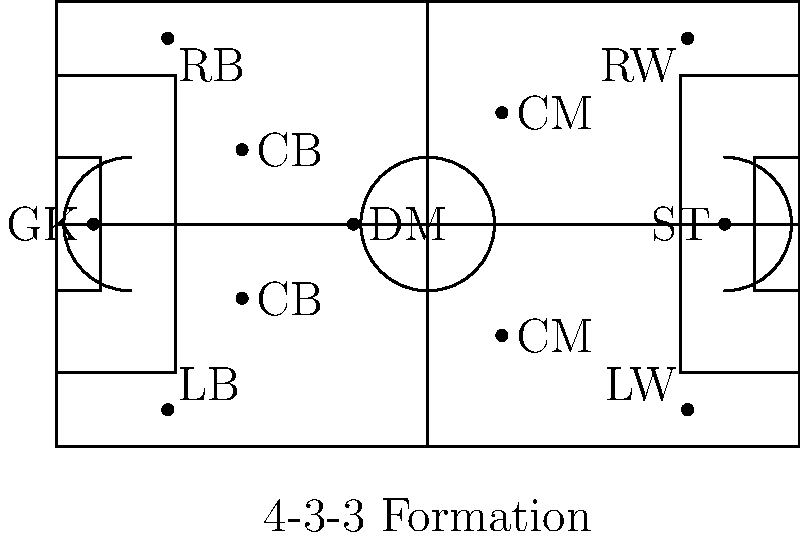Based on the diagram, which tactical formation is depicted, and how does it differ from the traditional 4-4-2 formation that was popular in Chilean football during the 1990s and early 2000s? To answer this question, let's analyze the diagram step-by-step:

1. Player positions:
   - 1 Goalkeeper (GK)
   - 4 Defenders: 2 Center-backs (CB), 1 Left-back (LB), 1 Right-back (RB)
   - 3 Midfielders: 1 Defensive midfielder (DM), 2 Central midfielders (CM)
   - 3 Forwards: 1 Striker (ST), 1 Left-winger (LW), 1 Right-winger (RW)

2. The formation shown is a 4-3-3, as indicated by the label at the bottom of the diagram.

3. Differences from the traditional 4-4-2 formation:
   a) Midfield structure:
      - 4-3-3 uses 3 midfielders (1 DM, 2 CM)
      - 4-4-2 typically uses 4 midfielders (2 central, 2 wide)

   b) Forward line:
      - 4-3-3 employs 3 forwards (1 ST, 2 wingers)
      - 4-4-2 uses 2 central strikers

   c) Defensive midfielder:
      - 4-3-3 often includes a dedicated defensive midfielder
      - 4-4-2 usually doesn't have a specialized DM role

   d) Width in attack:
      - 4-3-3 relies on wingers for width
      - 4-4-2 uses wide midfielders for width

   e) Pressing:
      - 4-3-3 allows for more aggressive high pressing with 3 forwards
      - 4-4-2 typically involves a more compact defensive shape

The 4-3-3 formation offers more flexibility in midfield and attack compared to the 4-4-2, allowing for better ball possession and creating numerical advantages in different areas of the pitch. This shift in tactical approach reflects the evolution of football strategy since the 1990s and early 2000s, emphasizing a more dynamic and fluid style of play.
Answer: 4-3-3 formation; more midfield control, wider attacking options, and increased pressing capability compared to 4-4-2. 